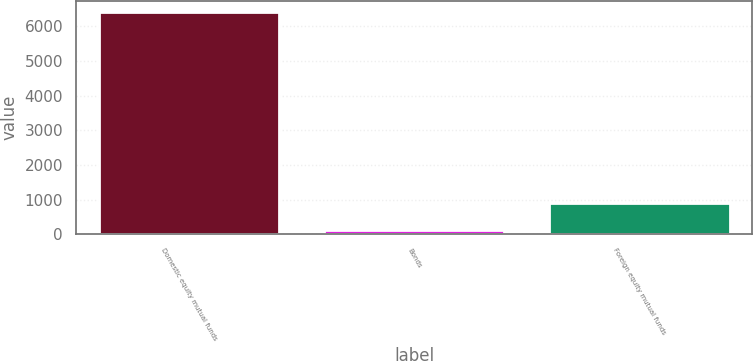<chart> <loc_0><loc_0><loc_500><loc_500><bar_chart><fcel>Domestic equity mutual funds<fcel>Bonds<fcel>Foreign equity mutual funds<nl><fcel>6419<fcel>108<fcel>905<nl></chart> 